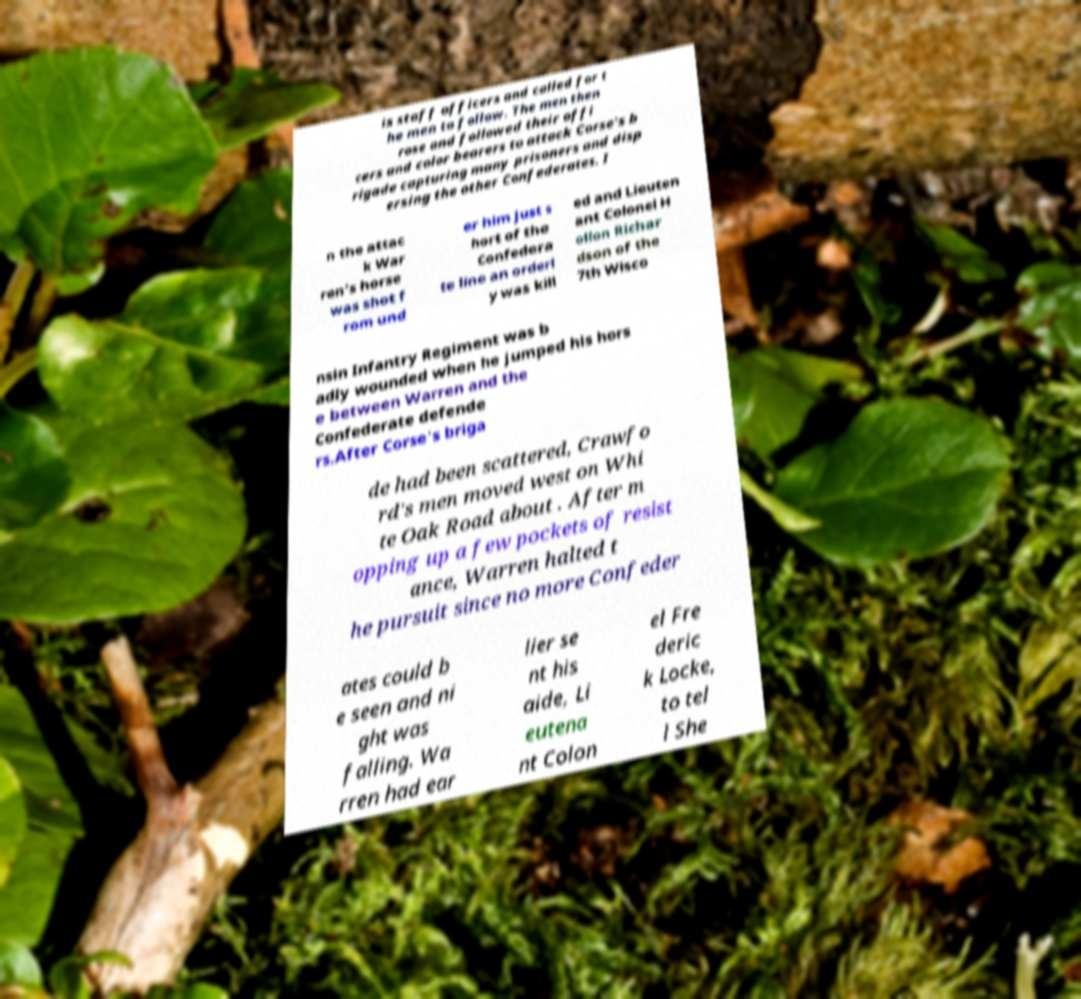Please identify and transcribe the text found in this image. is staff officers and called for t he men to follow. The men then rose and followed their offi cers and color bearers to attack Corse's b rigade capturing many prisoners and disp ersing the other Confederates. I n the attac k War ren's horse was shot f rom und er him just s hort of the Confedera te line an orderl y was kill ed and Lieuten ant Colonel H ollon Richar dson of the 7th Wisco nsin Infantry Regiment was b adly wounded when he jumped his hors e between Warren and the Confederate defende rs.After Corse's briga de had been scattered, Crawfo rd's men moved west on Whi te Oak Road about . After m opping up a few pockets of resist ance, Warren halted t he pursuit since no more Confeder ates could b e seen and ni ght was falling. Wa rren had ear lier se nt his aide, Li eutena nt Colon el Fre deric k Locke, to tel l She 